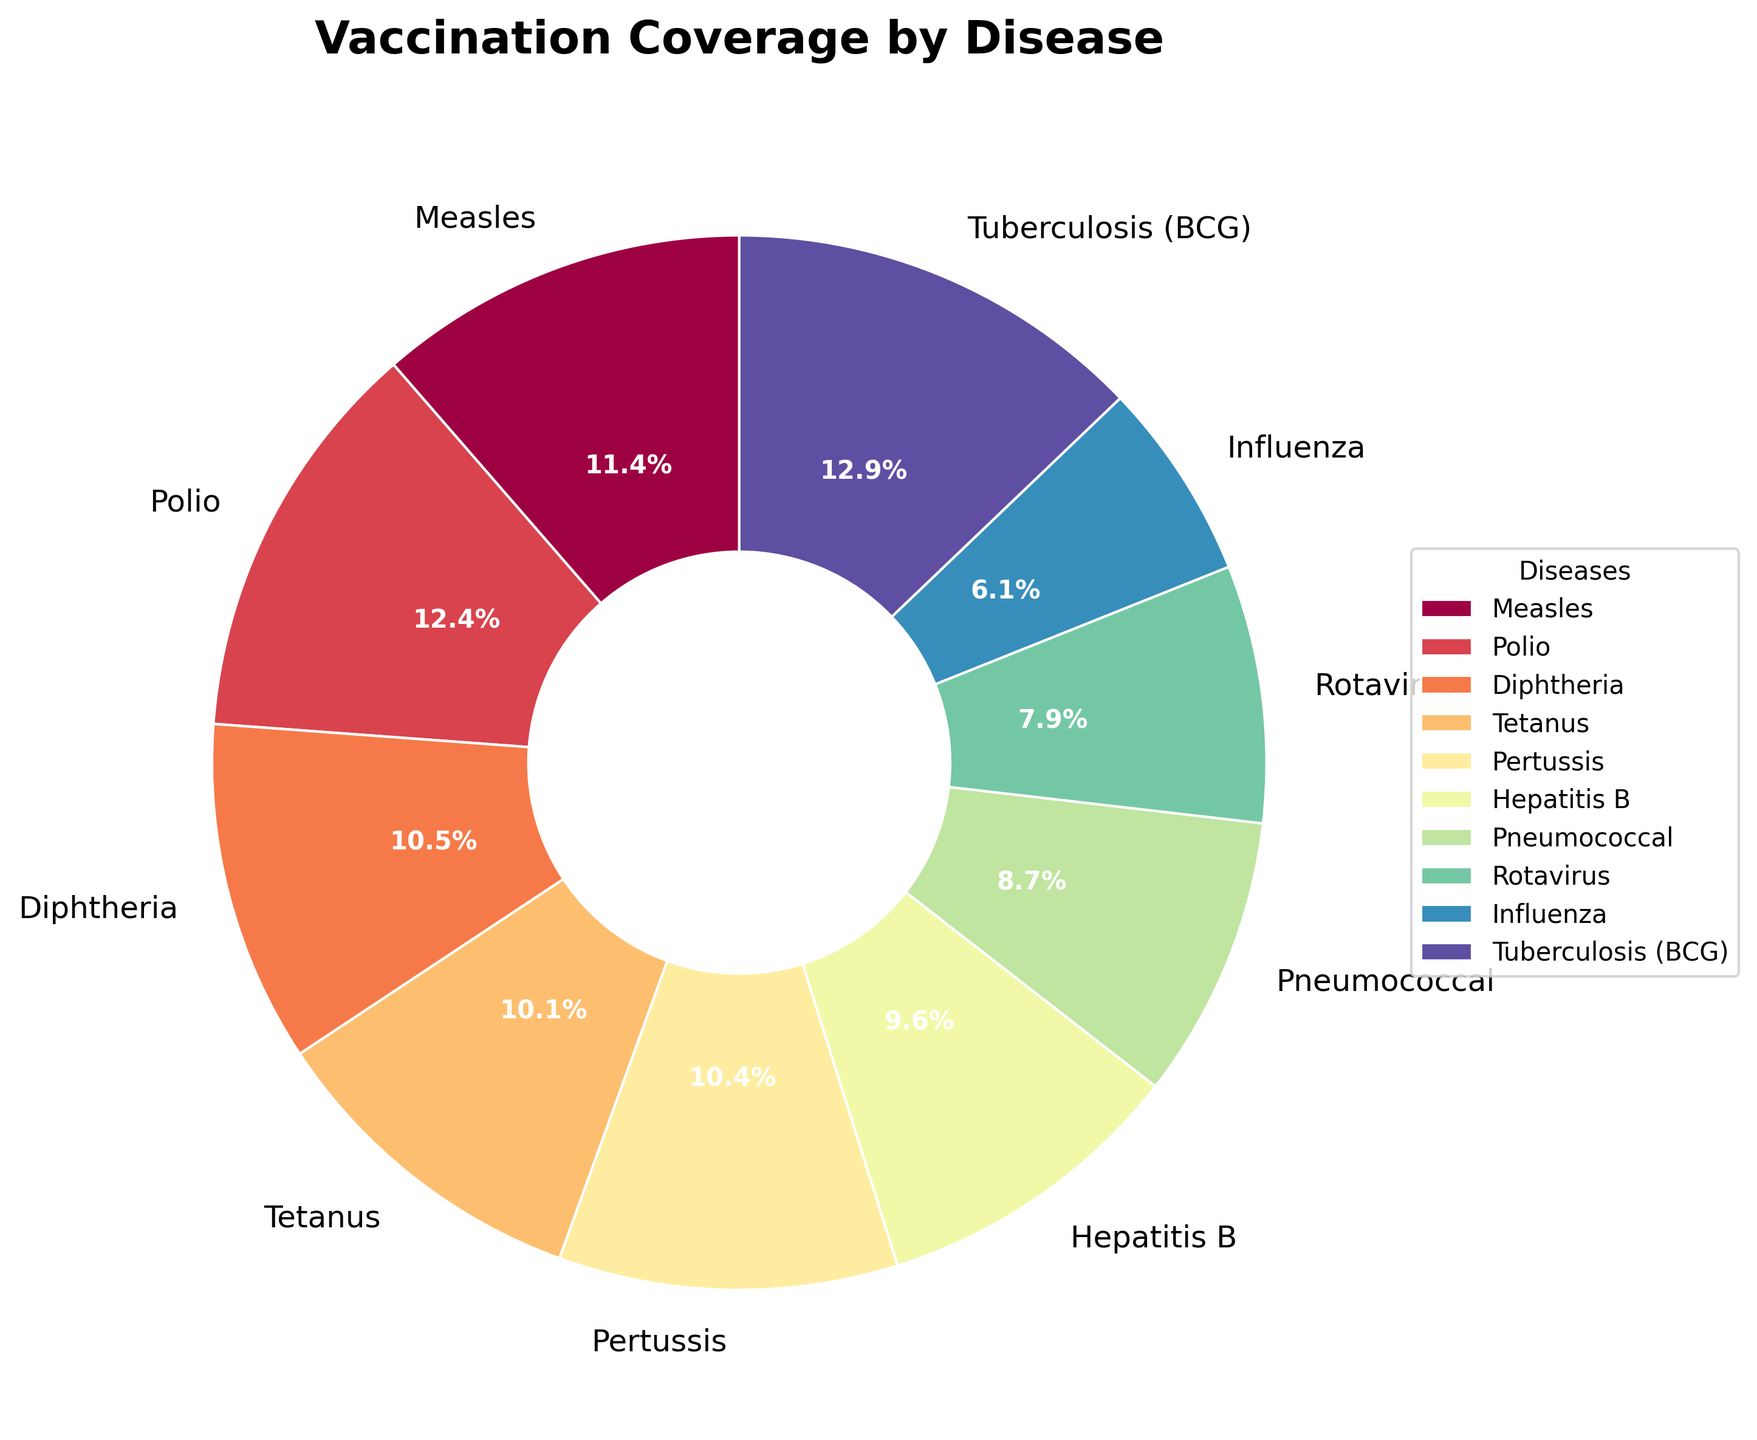How many diseases have a vaccination coverage above 80%? To determine the number of diseases with vaccination coverage above 80%, we look at the pie chart and count the segments with percentages greater than 80%. These diseases are Polio (85.6%) and Tuberculosis (BCG) (88.4%).
Answer: 2 Which disease has the lowest vaccination coverage? To find the disease with the lowest vaccination coverage, we identify the smallest segment in the pie chart. The smallest segment corresponds to Influenza, with a coverage of 41.9%.
Answer: Influenza What is the average vaccination coverage for Influenza, Rotavirus, and Pneumococcal? The percentages for Influenza, Rotavirus, and Pneumococcal are 41.9%, 54.3%, and 59.7% respectively. Sum up the percentages (41.9 + 54.3 + 59.7) = 155.9, and then divide by the number of diseases (3). 155.9 / 3 = 52.0%
Answer: 52.0% Which two diseases have the closest vaccination coverage values? To find which diseases have the closest vaccination coverage values, compare the percentages, looking for the smallest difference. Measles (78.3%) and Pertussis (71.5%) have a difference of 6.8%, but Measles (78.3%) and Diphtheria (72.1%) have an even smaller difference of 6.2%. Thus, Measles and Diphtheria have the closest coverage values.
Answer: Measles and Diphtheria What is the total vaccination coverage percentage for Measles, Polio, and Hepatitis B? Sum the percentages for Measles, Polio, and Hepatitis B. These values are 78.3%, 85.6%, and 66.2% respectively. Adding these values gives 78.3 + 85.6 + 66.2 = 230.1%.
Answer: 230.1% Which disease has a coverage slightly higher than the median? The diseases are ordered as follows from lowest to highest coverage: Influenza (41.9%), Rotavirus (54.3%), Pneumococcal (59.7%), Hepatitis B (66.2%), Tetanus (69.8%), Pertussis (71.5%), Diphtheria (72.1%), Measles (78.3%), Polio (85.6%), Tuberculosis (BCG, 88.4%). The median is the average of the 5th and 6th values (Tetanus and Pertussis), so (69.8% + 71.5%) / 2 = 70.65%. Therefore, Pertussis has a coverage slightly higher than the median.
Answer: Pertussis 